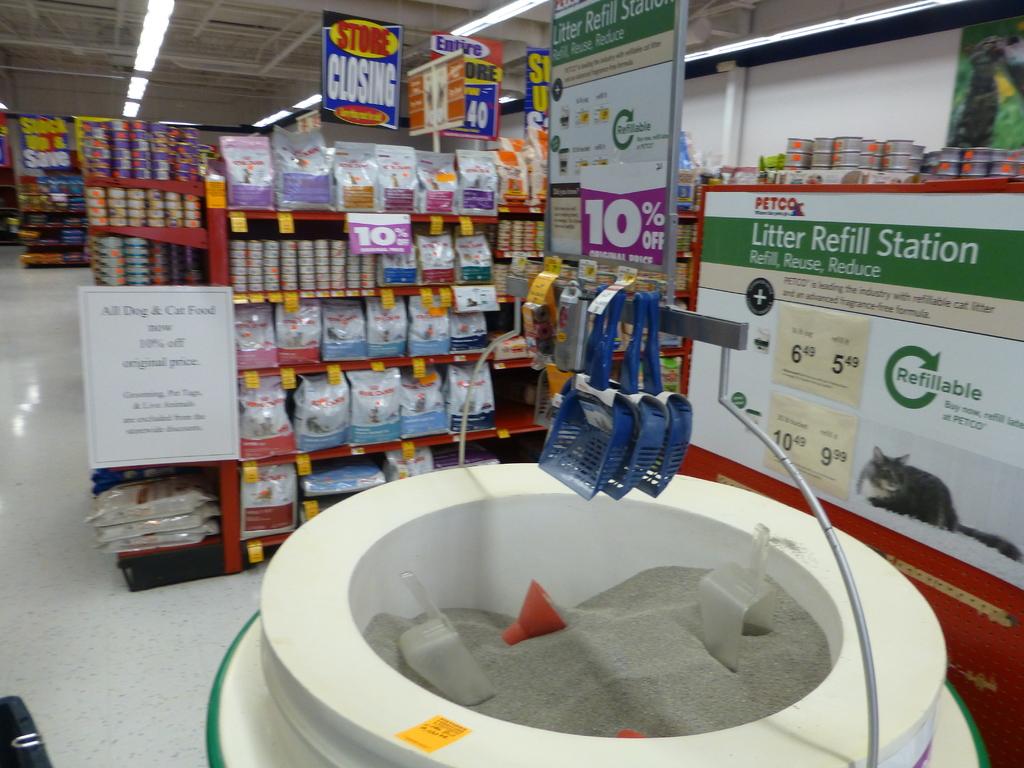Litter refill station?
Your answer should be compact. Yes. 